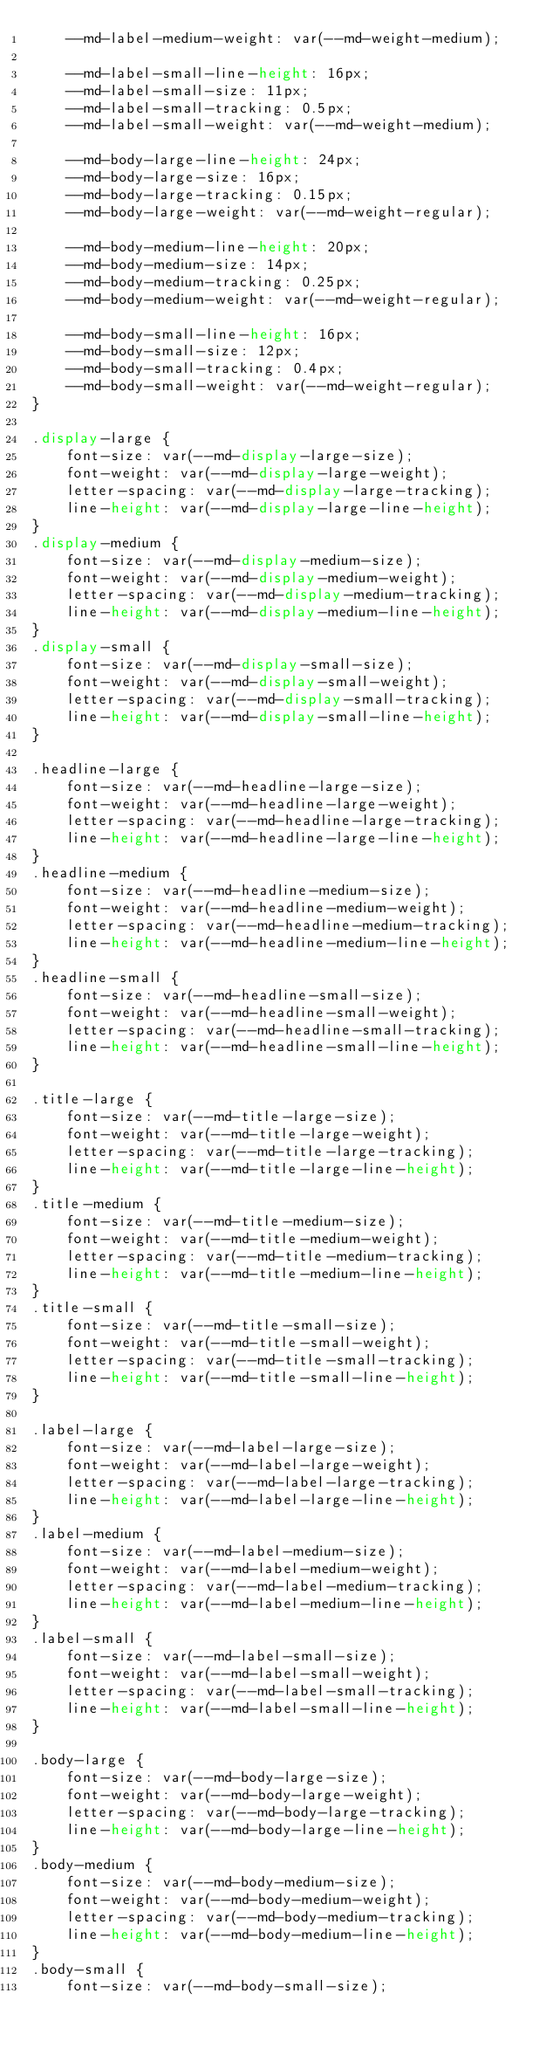<code> <loc_0><loc_0><loc_500><loc_500><_CSS_>    --md-label-medium-weight: var(--md-weight-medium);

    --md-label-small-line-height: 16px;
    --md-label-small-size: 11px;
    --md-label-small-tracking: 0.5px;
    --md-label-small-weight: var(--md-weight-medium);

    --md-body-large-line-height: 24px;
    --md-body-large-size: 16px;
    --md-body-large-tracking: 0.15px;
    --md-body-large-weight: var(--md-weight-regular);

    --md-body-medium-line-height: 20px;
    --md-body-medium-size: 14px;
    --md-body-medium-tracking: 0.25px;
    --md-body-medium-weight: var(--md-weight-regular);

    --md-body-small-line-height: 16px;
    --md-body-small-size: 12px;
    --md-body-small-tracking: 0.4px;
    --md-body-small-weight: var(--md-weight-regular);
}

.display-large {
    font-size: var(--md-display-large-size);
    font-weight: var(--md-display-large-weight);
    letter-spacing: var(--md-display-large-tracking);
    line-height: var(--md-display-large-line-height);
}
.display-medium {
    font-size: var(--md-display-medium-size);
    font-weight: var(--md-display-medium-weight);
    letter-spacing: var(--md-display-medium-tracking);
    line-height: var(--md-display-medium-line-height);
}
.display-small {
    font-size: var(--md-display-small-size);
    font-weight: var(--md-display-small-weight);
    letter-spacing: var(--md-display-small-tracking);
    line-height: var(--md-display-small-line-height);
}

.headline-large {
    font-size: var(--md-headline-large-size);
    font-weight: var(--md-headline-large-weight);
    letter-spacing: var(--md-headline-large-tracking);
    line-height: var(--md-headline-large-line-height);
}
.headline-medium {
    font-size: var(--md-headline-medium-size);
    font-weight: var(--md-headline-medium-weight);
    letter-spacing: var(--md-headline-medium-tracking);
    line-height: var(--md-headline-medium-line-height);
}
.headline-small {
    font-size: var(--md-headline-small-size);
    font-weight: var(--md-headline-small-weight);
    letter-spacing: var(--md-headline-small-tracking);
    line-height: var(--md-headline-small-line-height);
}

.title-large {
    font-size: var(--md-title-large-size);
    font-weight: var(--md-title-large-weight);
    letter-spacing: var(--md-title-large-tracking);
    line-height: var(--md-title-large-line-height);
}
.title-medium {
    font-size: var(--md-title-medium-size);
    font-weight: var(--md-title-medium-weight);
    letter-spacing: var(--md-title-medium-tracking);
    line-height: var(--md-title-medium-line-height);
}
.title-small {
    font-size: var(--md-title-small-size);
    font-weight: var(--md-title-small-weight);
    letter-spacing: var(--md-title-small-tracking);
    line-height: var(--md-title-small-line-height);
}

.label-large {
    font-size: var(--md-label-large-size);
    font-weight: var(--md-label-large-weight);
    letter-spacing: var(--md-label-large-tracking);
    line-height: var(--md-label-large-line-height);
}
.label-medium {
    font-size: var(--md-label-medium-size);
    font-weight: var(--md-label-medium-weight);
    letter-spacing: var(--md-label-medium-tracking);
    line-height: var(--md-label-medium-line-height);
}
.label-small {
    font-size: var(--md-label-small-size);
    font-weight: var(--md-label-small-weight);
    letter-spacing: var(--md-label-small-tracking);
    line-height: var(--md-label-small-line-height);
}

.body-large {
    font-size: var(--md-body-large-size);
    font-weight: var(--md-body-large-weight);
    letter-spacing: var(--md-body-large-tracking);
    line-height: var(--md-body-large-line-height);
}
.body-medium {
    font-size: var(--md-body-medium-size);
    font-weight: var(--md-body-medium-weight);
    letter-spacing: var(--md-body-medium-tracking);
    line-height: var(--md-body-medium-line-height);
}
.body-small {
    font-size: var(--md-body-small-size);</code> 